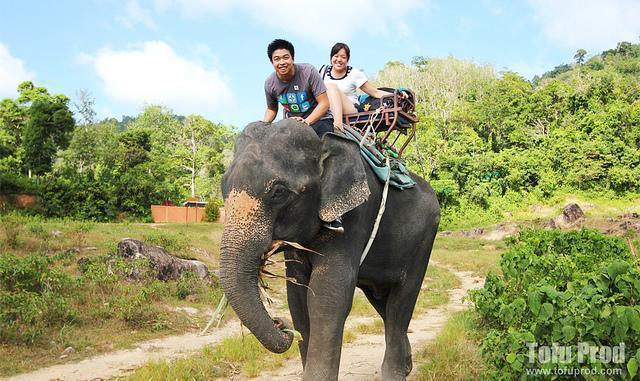How many people are there?
Give a very brief answer. 2. How many benches are in the picture?
Give a very brief answer. 1. 